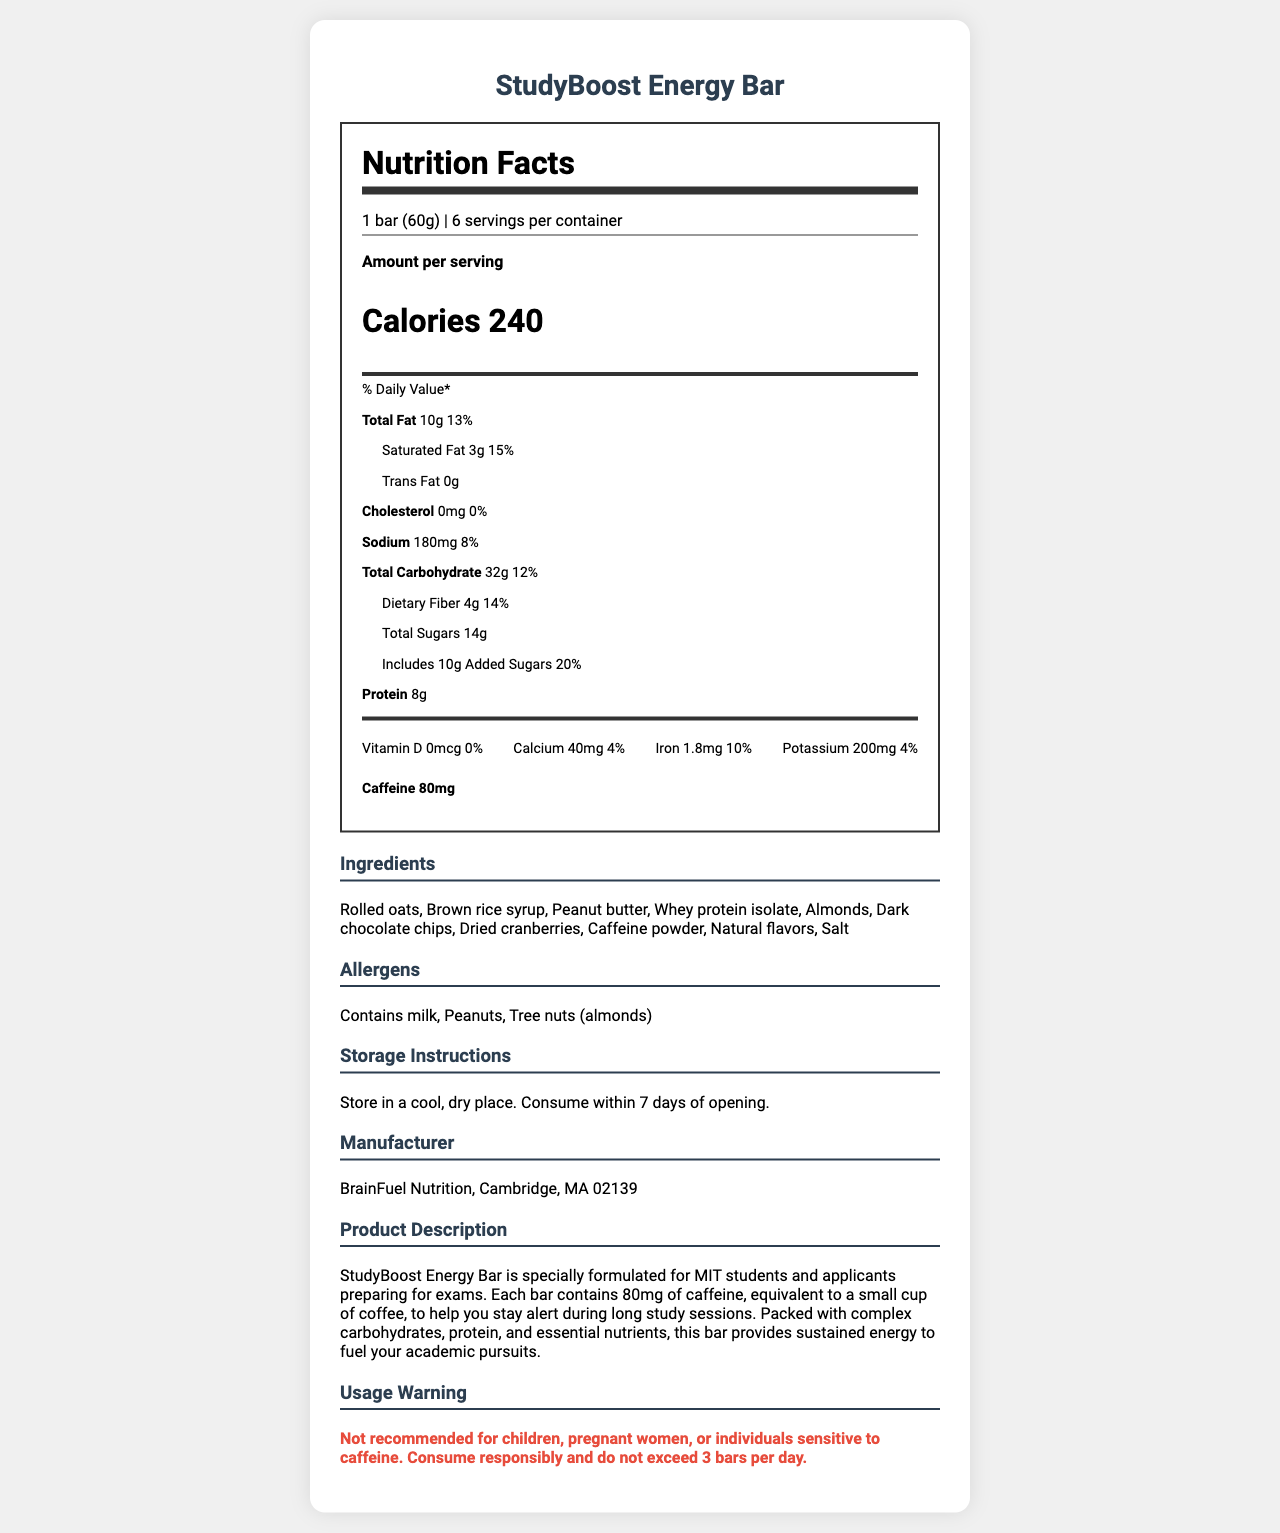what is the serving size of StudyBoost Energy Bar? The serving size is directly mentioned as "1 bar (60g)" under the nutrition facts.
Answer: 1 bar (60g) how many servings are there per container? The document states "6 servings per container."
Answer: 6 how many grams of total carbohydrates are in one serving? The total carbohydrate amount per serving is listed as 32g.
Answer: 32g how much caffeine does one bar contain? The caffeine content is specified as 80mg.
Answer: 80mg how many grams of protein are in one serving? The amount of protein per serving is provided as 8g.
Answer: 8g What percentage of the daily value of saturated fat does one bar provide? The document states that the daily value of saturated fat per bar is 15%.
Answer: 15% where should you store the StudyBoost Energy Bar? The storage instructions specify to "Store in a cool, dry place."
Answer: Store in a cool, dry place. how many calories are in one bar? The document mentions that there are 240 calories per serving.
Answer: 240 which company manufactures the StudyBoost Energy Bar? The manufacturer is listed as BrainFuel Nutrition, Cambridge, MA 02139.
Answer: BrainFuel Nutrition, Cambridge, MA 02139 True or False: The StudyBoost Energy Bar contains trans fat. The document indicates that there is 0g of trans fat.
Answer: False What is the main idea of the document? The document provides comprehensive nutritional facts, ingredients, and other information regarding the StudyBoost Energy Bar, which is a caffeinated snack meant to help students stay alert during study sessions.
Answer: The StudyBoost Energy Bar provides nutritional information for a caffeinated snack bar designed for students preparing for exams, including serving size, calorie count, macronutrient and micronutrient content, ingredients, allergens, storage instructions, and usage warnings. which of the following is NOT an ingredient in the StudyBoost Energy Bar? A. Rolled oats B. Whey protein isolate C. Artificial flavors D. Salt The listed ingredients mention "Natural flavors" but not "Artificial flavors."
Answer: C. Artificial flavors which of the following nutrients is present in the highest daily value percentage in one bar? A. Dietary Fiber B. Calcium C. Added Sugars D. Iron Added Sugars have the highest daily value percentage at 20%.
Answer: C. Added Sugars how much sodium is in one serving? The sodium content per serving is listed as 180mg.
Answer: 180mg are there any milk allergens present in the StudyBoost Energy Bar? The document states that the product "Contains milk" as an allergen.
Answer: Yes can this document tell us if the StudyBoost Energy Bar is gluten-free? The document provides ingredient and allergen information, but does not specify if the product is gluten-free.
Answer: Not enough information 